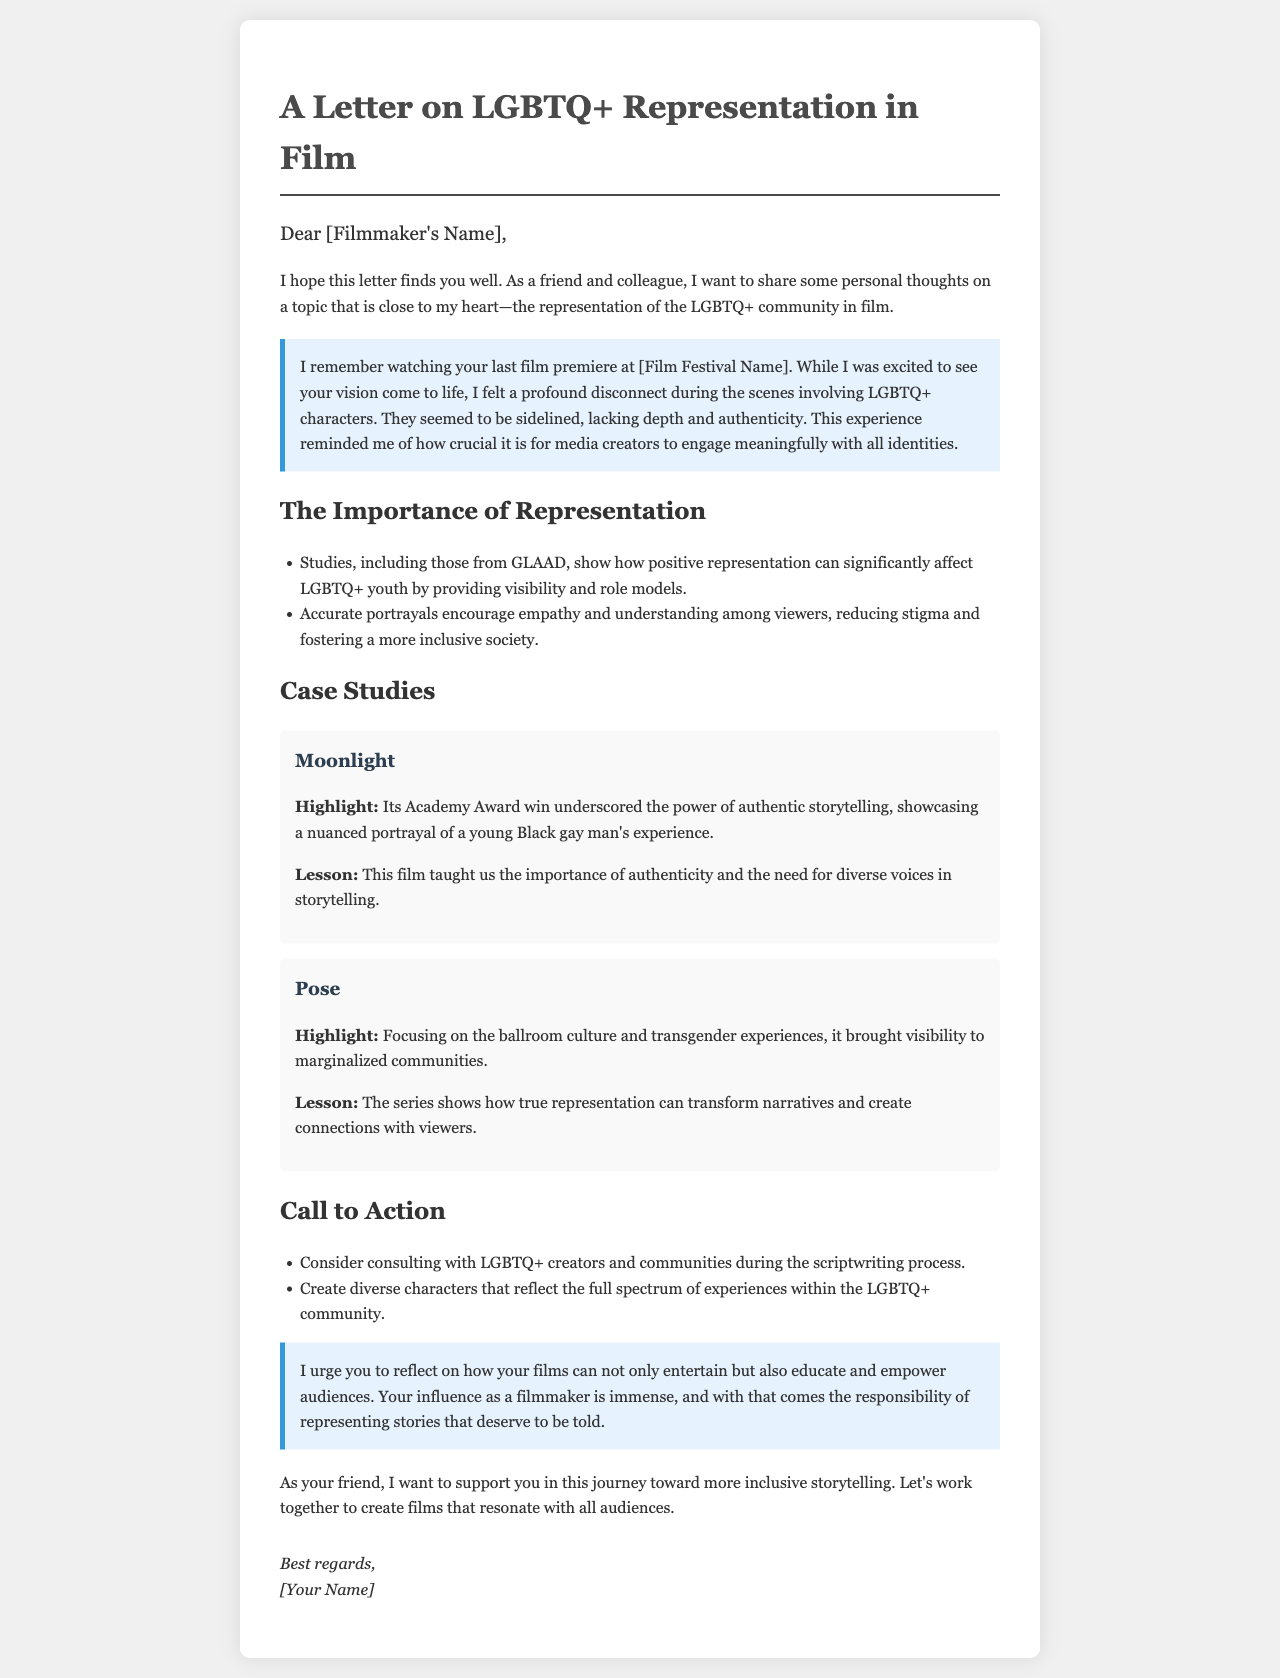What film festival is mentioned in the letter? The letter references a film festival where the filmmaker's last film premiered, but the specific name is not provided; it is indicated as [Film Festival Name].
Answer: [Film Festival Name] What are the titles of the case studies mentioned? The two case studies presented in the letter are "Moonlight" and "Pose."
Answer: Moonlight, Pose What is highlighted about the film "Moonlight"? "Moonlight" is highlighted for its Academy Award win and for showcasing a nuanced portrayal of a young Black gay man's experience.
Answer: Academy Award win What does the letter suggest for creating diverse characters? The letter recommends creating characters that reflect the full spectrum of experiences within the LGBTQ+ community.
Answer: Full spectrum of experiences What responsibility does the filmmaker have according to the letter? The letter states that the filmmaker has the responsibility of representing stories that deserve to be told.
Answer: Responsibility of representing stories 